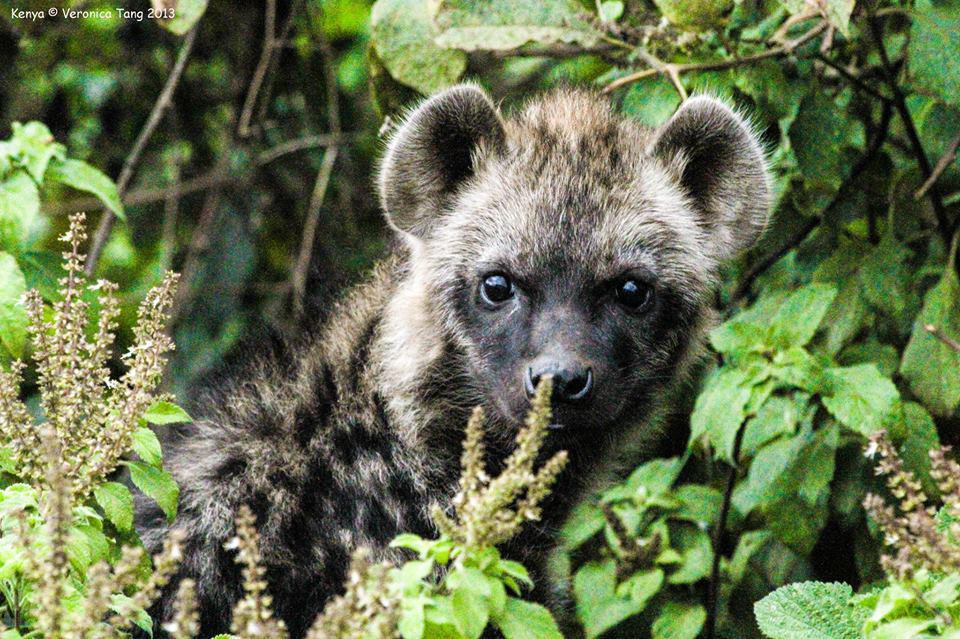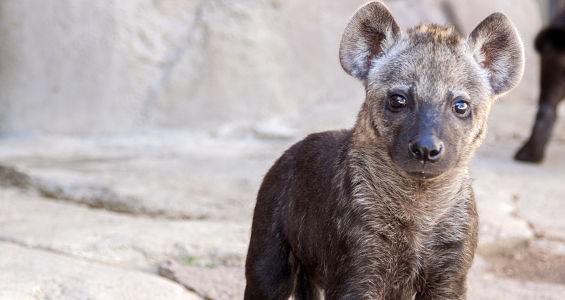The first image is the image on the left, the second image is the image on the right. Given the left and right images, does the statement "The lefthand image includes multiple hyenas, and at least one hyena stands with its nose bent to the ground." hold true? Answer yes or no. No. The first image is the image on the left, the second image is the image on the right. Examine the images to the left and right. Is the description "There are four hyenas." accurate? Answer yes or no. No. 